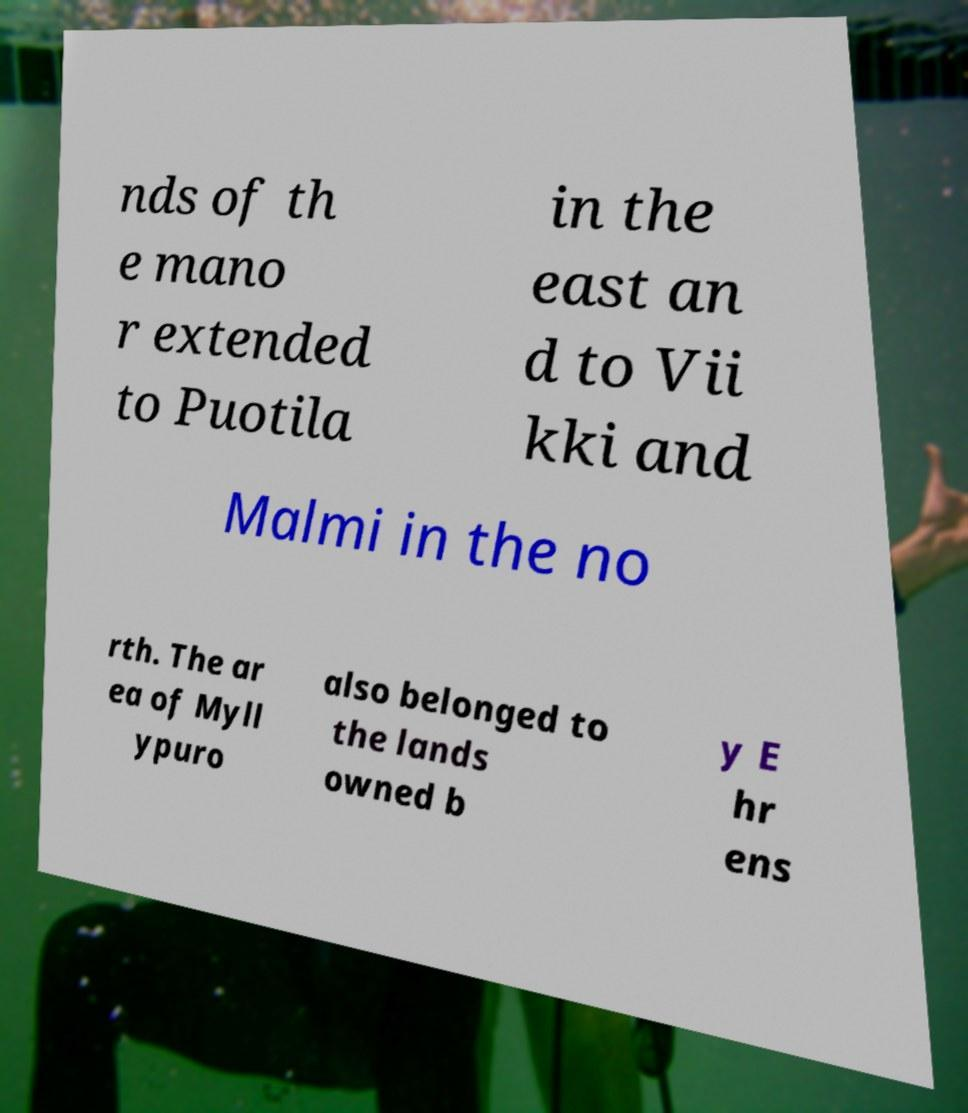I need the written content from this picture converted into text. Can you do that? nds of th e mano r extended to Puotila in the east an d to Vii kki and Malmi in the no rth. The ar ea of Myll ypuro also belonged to the lands owned b y E hr ens 